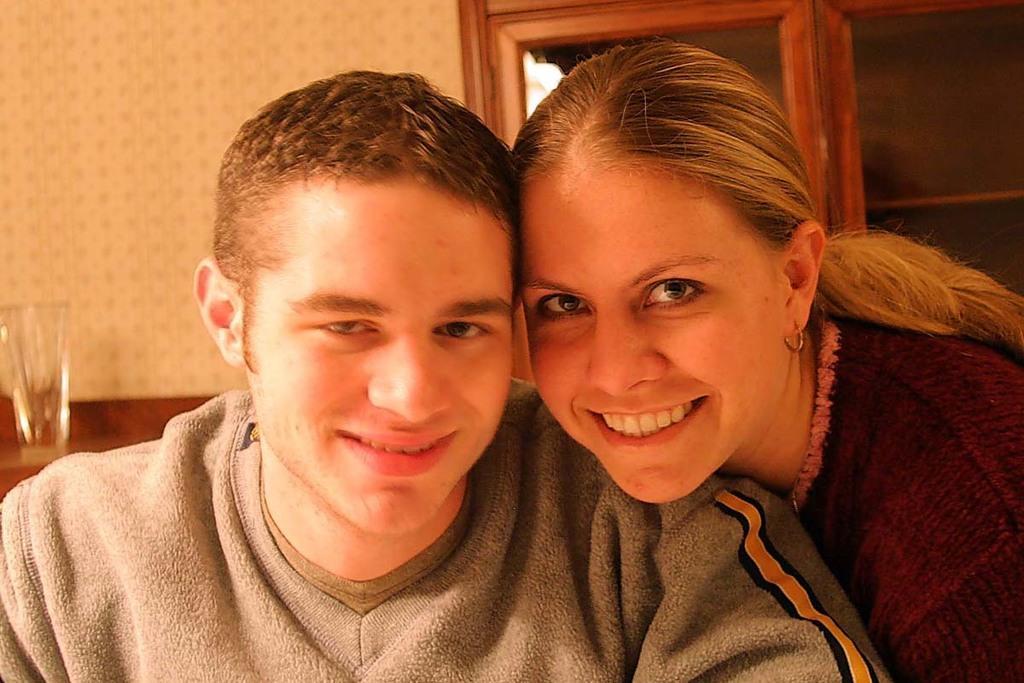In one or two sentences, can you explain what this image depicts? Here I can see a man and a woman are smiling and looking at the picture. In the background there is a wall and a door. On the left side there is a glass on a table. 